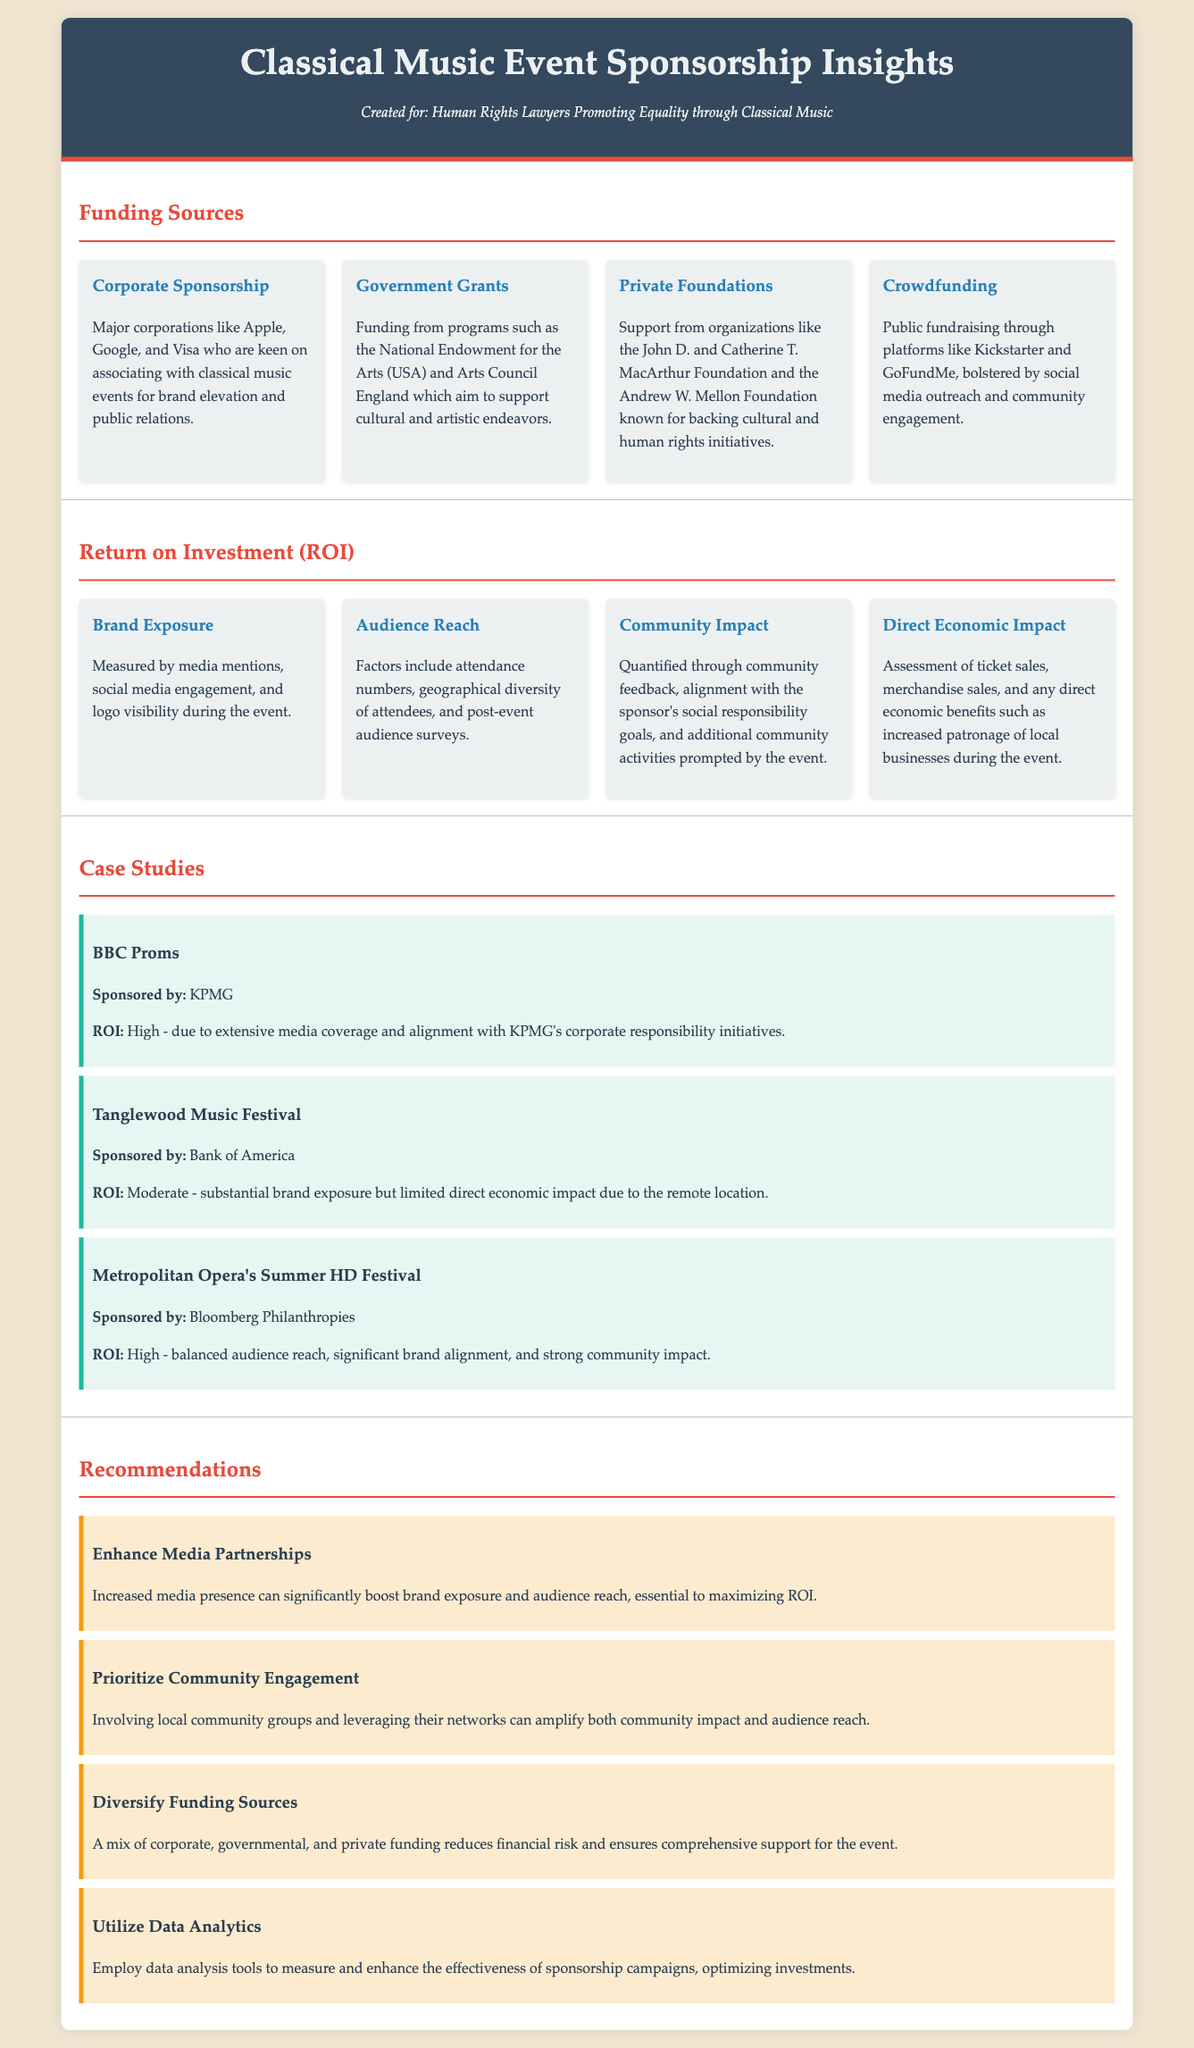What are the major corporations associated with sponsorship? The document lists major corporations like Apple, Google, and Visa who are interested in sponsoring classical music events.
Answer: Apple, Google, Visa What is a funding source mentioned in the document? The document identifies various funding sources, including corporate sponsorship, government grants, private foundations, and crowdfunding.
Answer: Corporate sponsorship What is the ROI for the BBC Proms? The document specifies that the ROI for the BBC Proms is high due to extensive media coverage and alignment with corporate responsibility initiatives.
Answer: High Which festival is sponsored by Bank of America? The document states that the Tanglewood Music Festival is sponsored by Bank of America.
Answer: Tanglewood Music Festival What is one recommendation for enhancing sponsorship effectiveness? The document suggests that enhancing media partnerships can significantly boost brand exposure and audience reach.
Answer: Enhance Media Partnerships What method is suggested for measuring sponsorship effectiveness? The document recommends employing data analysis tools to measure and enhance the effectiveness of sponsorship campaigns.
Answer: Data Analytics What type of funding reduces financial risk? The document indicates that diversifying funding sources can reduce financial risk for classical music events.
Answer: Diversify Funding Sources Which foundation is mentioned as a supporter of cultural initiatives? The document references the John D. and Catherine T. MacArthur Foundation as a supporter of cultural initiatives.
Answer: John D. and Catherine T. MacArthur Foundation What is the focus of the insights provided in the document? The insights provided in the document center around Classical Music Event Sponsorship, particularly funding sources and return on investment.
Answer: Classical Music Event Sponsorship Insights 